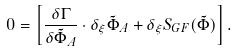Convert formula to latex. <formula><loc_0><loc_0><loc_500><loc_500>0 = \left [ \frac { \delta \Gamma } { \delta \tilde { \Phi } _ { A } } \cdot \delta _ { \xi } \tilde { \Phi } _ { A } + \delta _ { \xi } S _ { G F } ( \tilde { \Phi } ) \right ] .</formula> 